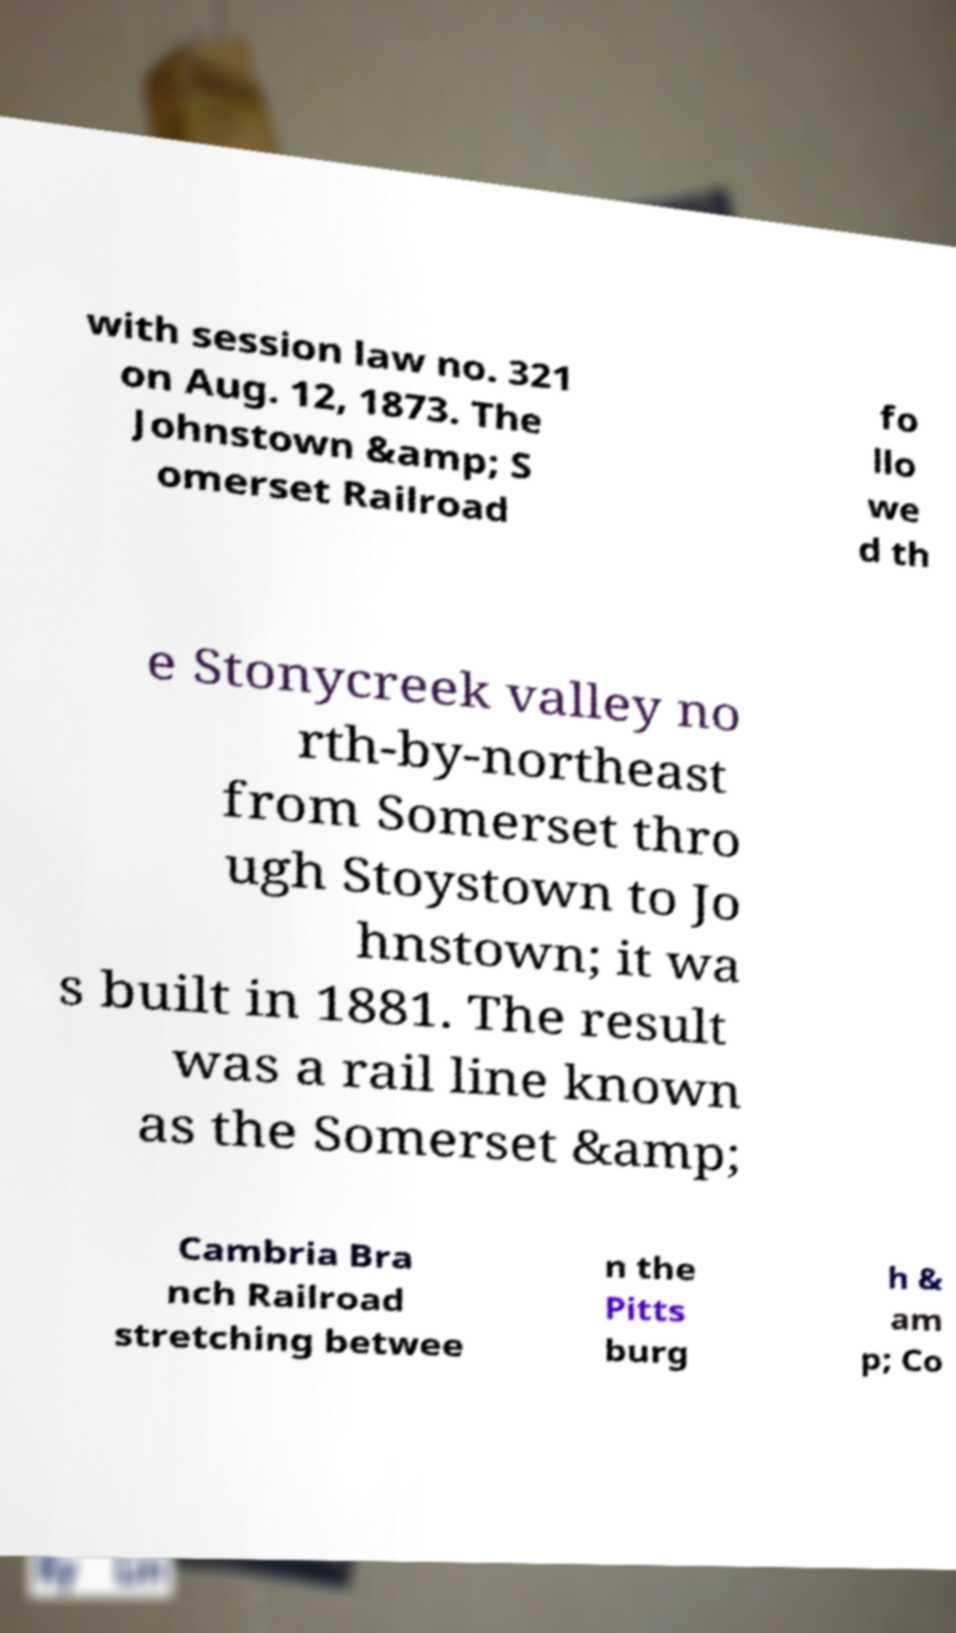Could you assist in decoding the text presented in this image and type it out clearly? with session law no. 321 on Aug. 12, 1873. The Johnstown &amp; S omerset Railroad fo llo we d th e Stonycreek valley no rth-by-northeast from Somerset thro ugh Stoystown to Jo hnstown; it wa s built in 1881. The result was a rail line known as the Somerset &amp; Cambria Bra nch Railroad stretching betwee n the Pitts burg h & am p; Co 